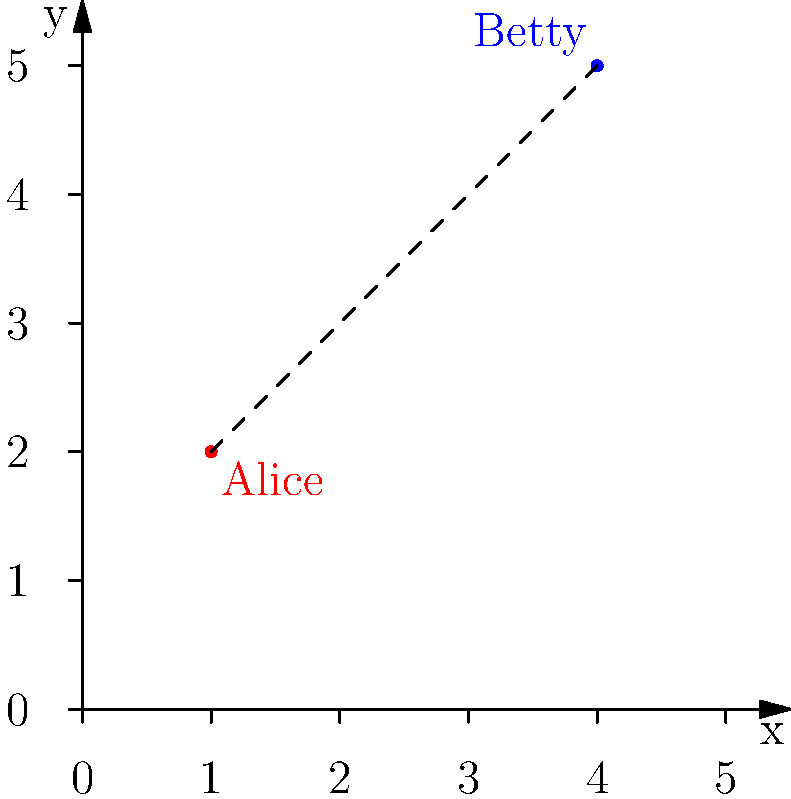At your high school reunion, Alice and Betty are standing at different spots in the room. Their positions can be represented by vector coordinates on a grid. Alice is at $(1,2)$ and Betty is at $(4,5)$. What is the distance between them? To find the distance between Alice and Betty, we can use the distance formula, which is derived from the Pythagorean theorem:

1) The distance formula is: $d = \sqrt{(x_2-x_1)^2 + (y_2-y_1)^2}$

2) Alice's coordinates: $(x_1,y_1) = (1,2)$
   Betty's coordinates: $(x_2,y_2) = (4,5)$

3) Plugging these into the formula:
   $d = \sqrt{(4-1)^2 + (5-2)^2}$

4) Simplify inside the parentheses:
   $d = \sqrt{3^2 + 3^2}$

5) Calculate the squares:
   $d = \sqrt{9 + 9}$

6) Add inside the square root:
   $d = \sqrt{18}$

7) Simplify the square root:
   $d = 3\sqrt{2}$

Therefore, the distance between Alice and Betty is $3\sqrt{2}$ units.
Answer: $3\sqrt{2}$ units 